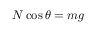<formula> <loc_0><loc_0><loc_500><loc_500>N \cos \theta = m g</formula> 